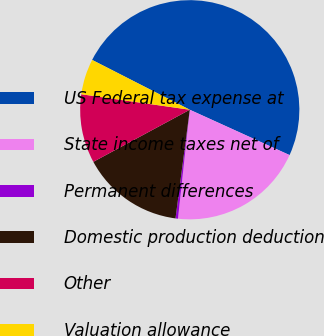Convert chart. <chart><loc_0><loc_0><loc_500><loc_500><pie_chart><fcel>US Federal tax expense at<fcel>State income taxes net of<fcel>Permanent differences<fcel>Domestic production deduction<fcel>Other<fcel>Valuation allowance<nl><fcel>49.28%<fcel>19.93%<fcel>0.36%<fcel>15.04%<fcel>10.14%<fcel>5.25%<nl></chart> 